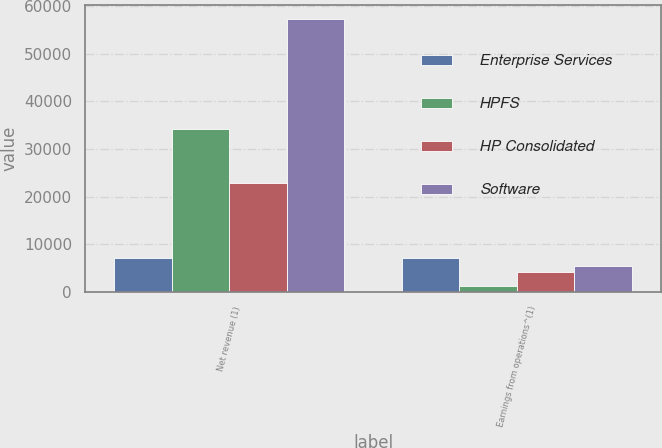Convert chart. <chart><loc_0><loc_0><loc_500><loc_500><stacked_bar_chart><ecel><fcel>Net revenue (1)<fcel>Earnings from operations^(1)<nl><fcel>Enterprise Services<fcel>7185<fcel>7185<nl><fcel>HPFS<fcel>34303<fcel>1270<nl><fcel>HP Consolidated<fcel>22979<fcel>4185<nl><fcel>Software<fcel>57282<fcel>5455<nl></chart> 